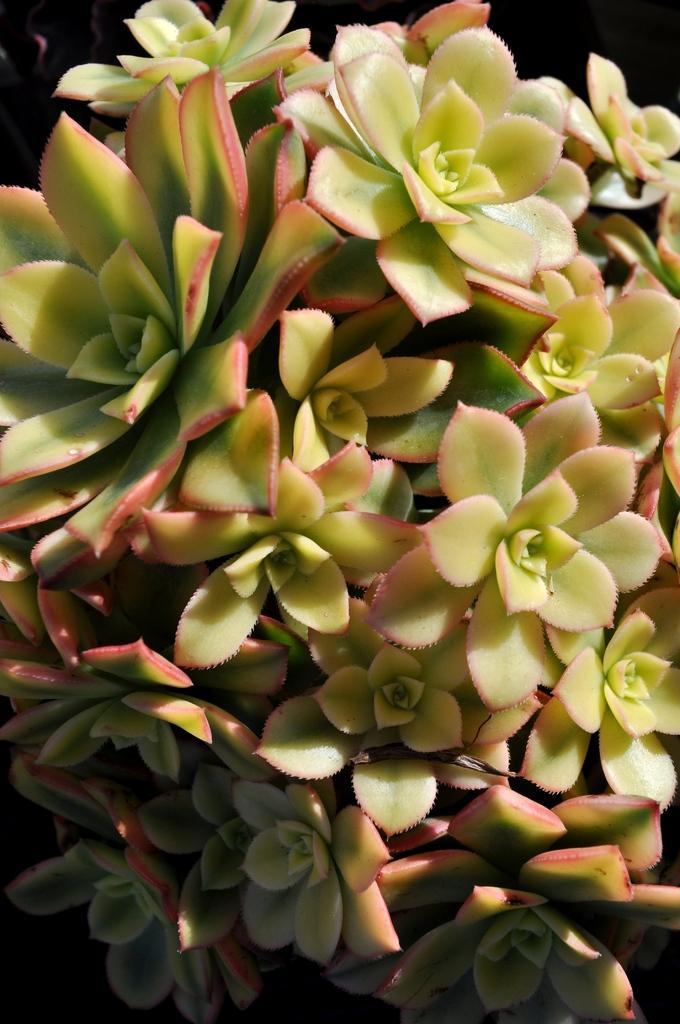How would you summarize this image in a sentence or two? We can see flowers. In the background it is dark. 